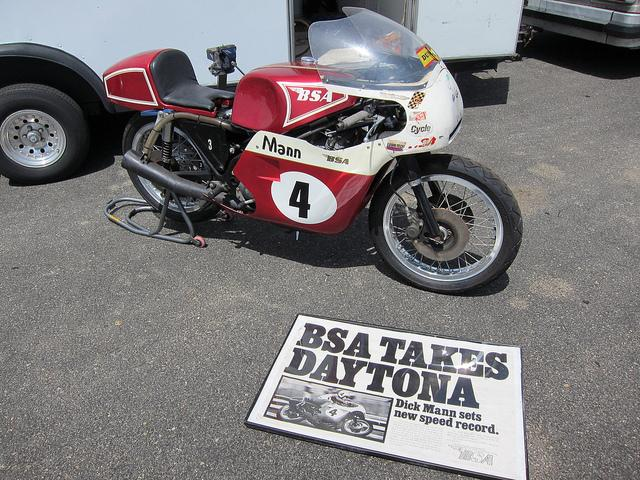What is the first name of the person who rode this bike?

Choices:
A) mary
B) mann
C) dick
D) manny dick 